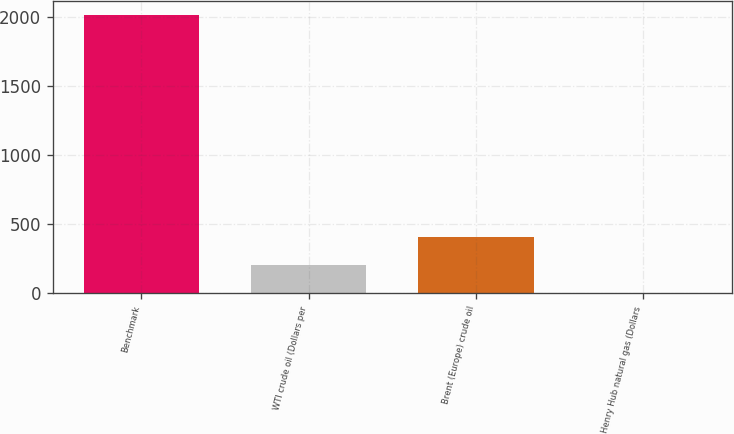Convert chart. <chart><loc_0><loc_0><loc_500><loc_500><bar_chart><fcel>Benchmark<fcel>WTI crude oil (Dollars per<fcel>Brent (Europe) crude oil<fcel>Henry Hub natural gas (Dollars<nl><fcel>2013<fcel>204.59<fcel>405.52<fcel>3.65<nl></chart> 